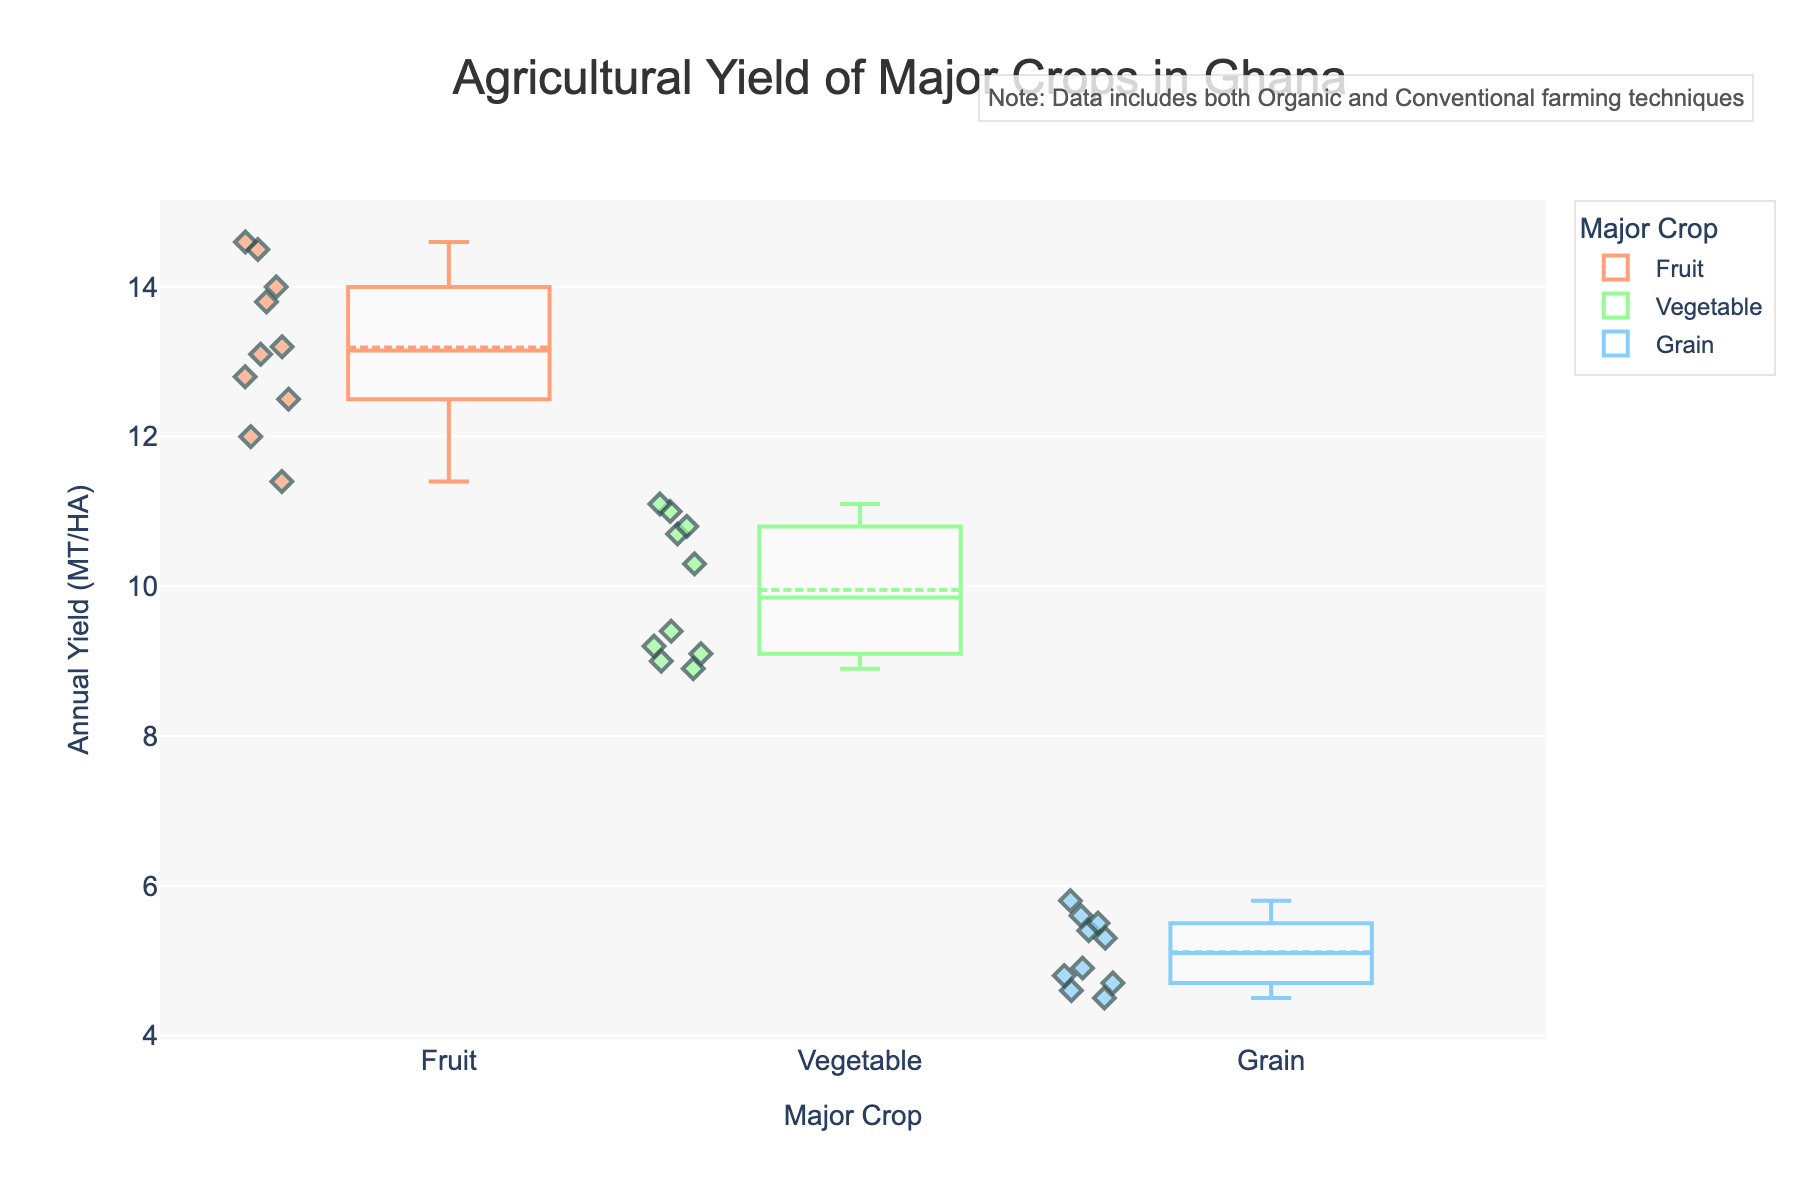What's the title of the figure? The title is usually placed at the top of the figure. In this case, the title is located at the top center and is displayed in a large, bold font.
Answer: Agricultural Yield of Major Crops in Ghana What does the y-axis represent? The y-axis label is usually found on the left side of the figure. Here, the y-axis represents the annual yield in metric tons per hectare (MT/HA).
Answer: Annual Yield (MT/HA) Which crop has the highest upper whisker value? Look for the crop with the whisker reaching the highest point on the y-axis. According to the figure, the upper whisker for Fruits has the highest value.
Answer: Fruit What is the median yield for vegetables? The median is indicated by a line inside the box. For vegetables, locate the middle line in the green box plot representing vegetables.
Answer: Approximately 10 MT/HA Compare the average yields of Organic and Conventional farming techniques for Vegetables. Which one is higher? Comparing the box plots for Vegetables, look at the box's position and the scatter points around it. The average can be deduced from the central markers. Conventional farming generally shows a higher position, indicating a higher average yield.
Answer: Conventional What does the annotation at the top right corner mention? Read the text in the annotation box found at the top right of the figure.
Answer: Note: Data includes both Organic and Conventional farming techniques Which crop has the smallest interquartile range (IQR)? The IQR is the height of the box. Locate the shortest box. In this figure, the box representing Grain appears to have the smallest height.
Answer: Grain Identify the farming technique and crop with the lowest yield data point. Look for the smallest individual scatter point among all box plots. The lowest point appears in the Grain category, more specifically for the Organic farming technique.
Answer: Organic Grain What is the mean yield for Grains and how is it displayed in the figure? The mean value is often shown by a small marker (like a diamond) within the box plot. For Grains, locate this marker in the blue box for the mean value.
Answer: Approximately 5 MT/HA How do the yields of Organic Fruits compare to Conventional Fruits? Compare the positions of the box plots and the scatter points for Fruits between Organic and Conventional farming methods. Conventional Fruits consistently show higher yields on average.
Answer: Conventional Fruits yield more 